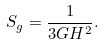<formula> <loc_0><loc_0><loc_500><loc_500>S _ { g } = \frac { 1 } { 3 G H ^ { 2 } } .</formula> 